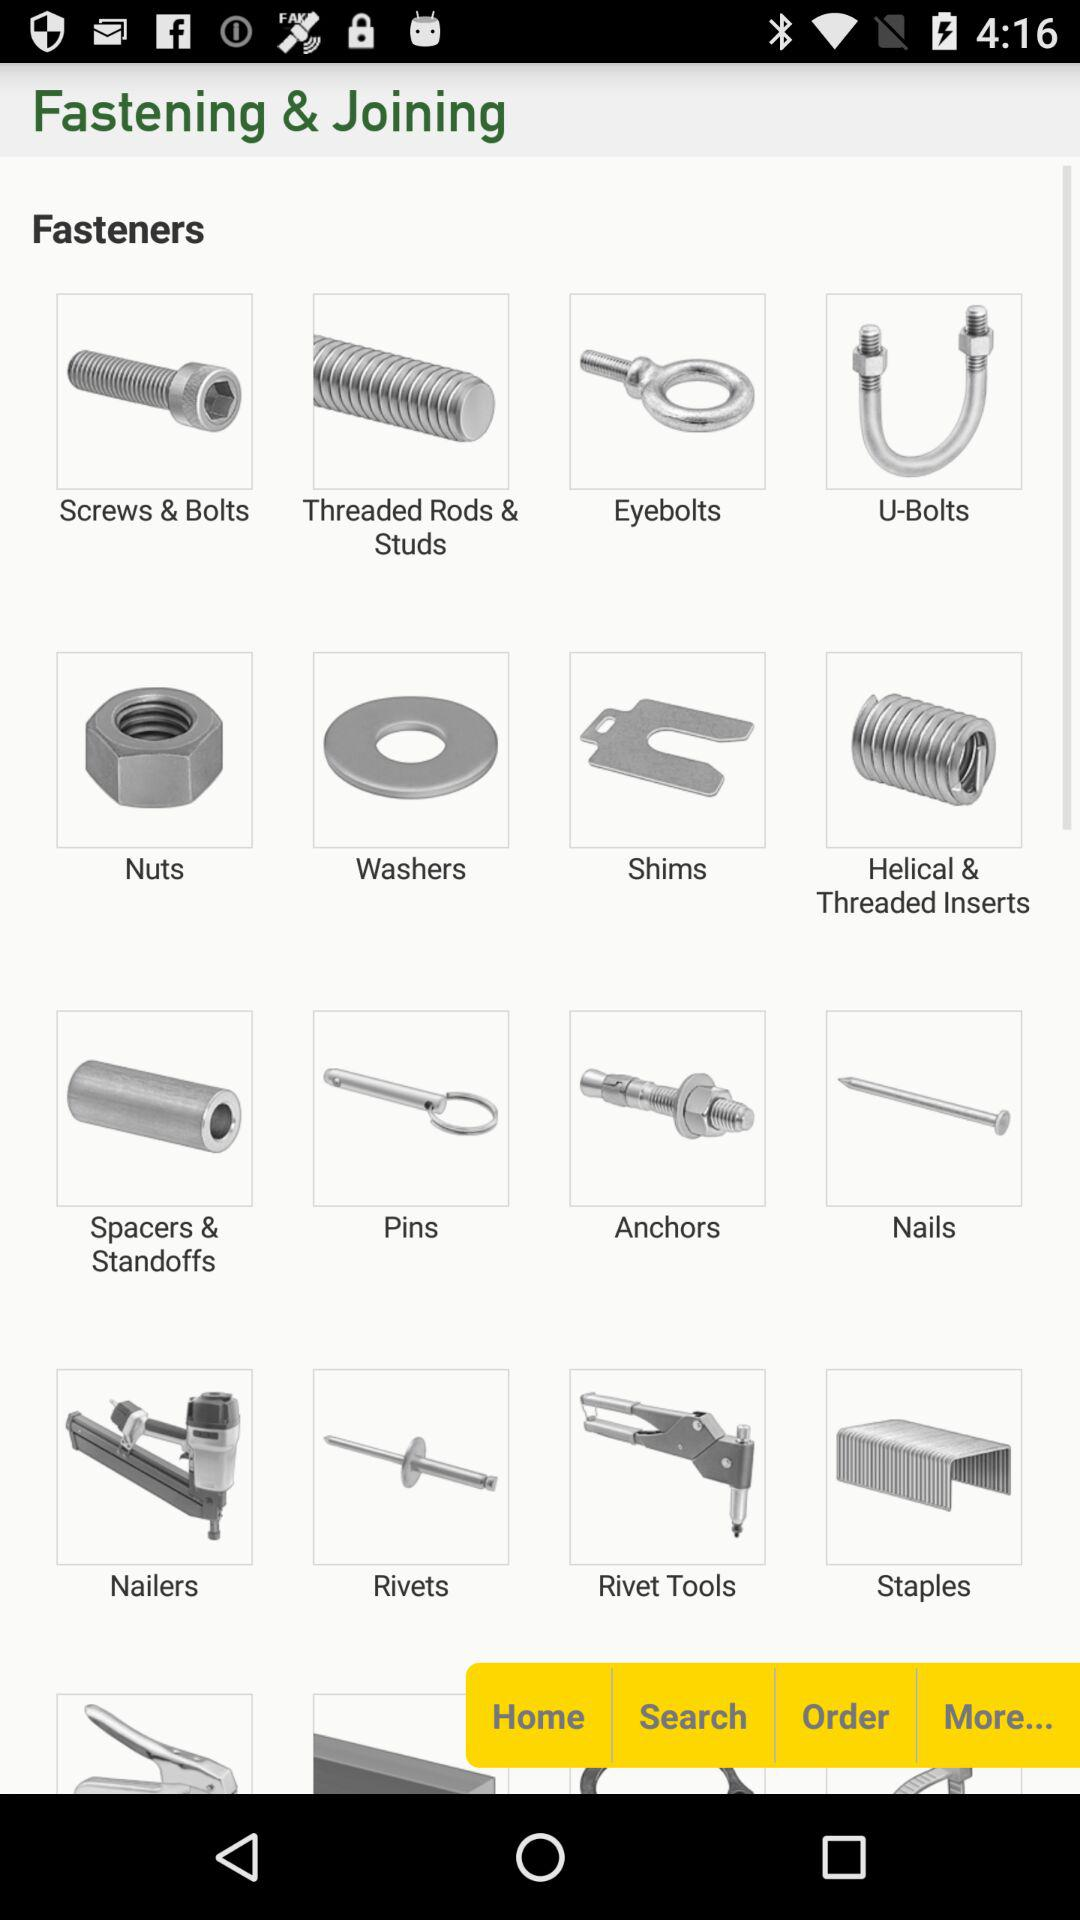What types of fasteners are there? The type of fasteners are "Screws & Bolts", "Threaded Rods & Studs", "Eyebolts", "U-Bolts", "Nuts", "Washers", "Shims", "Helical & Threaded Inserts", "Spacers & Standoffs", "Pins", "Anchors", "Nails", "Nailers", "Rivets", "Rivet Tools" and "Staples". 